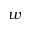<formula> <loc_0><loc_0><loc_500><loc_500>w</formula> 